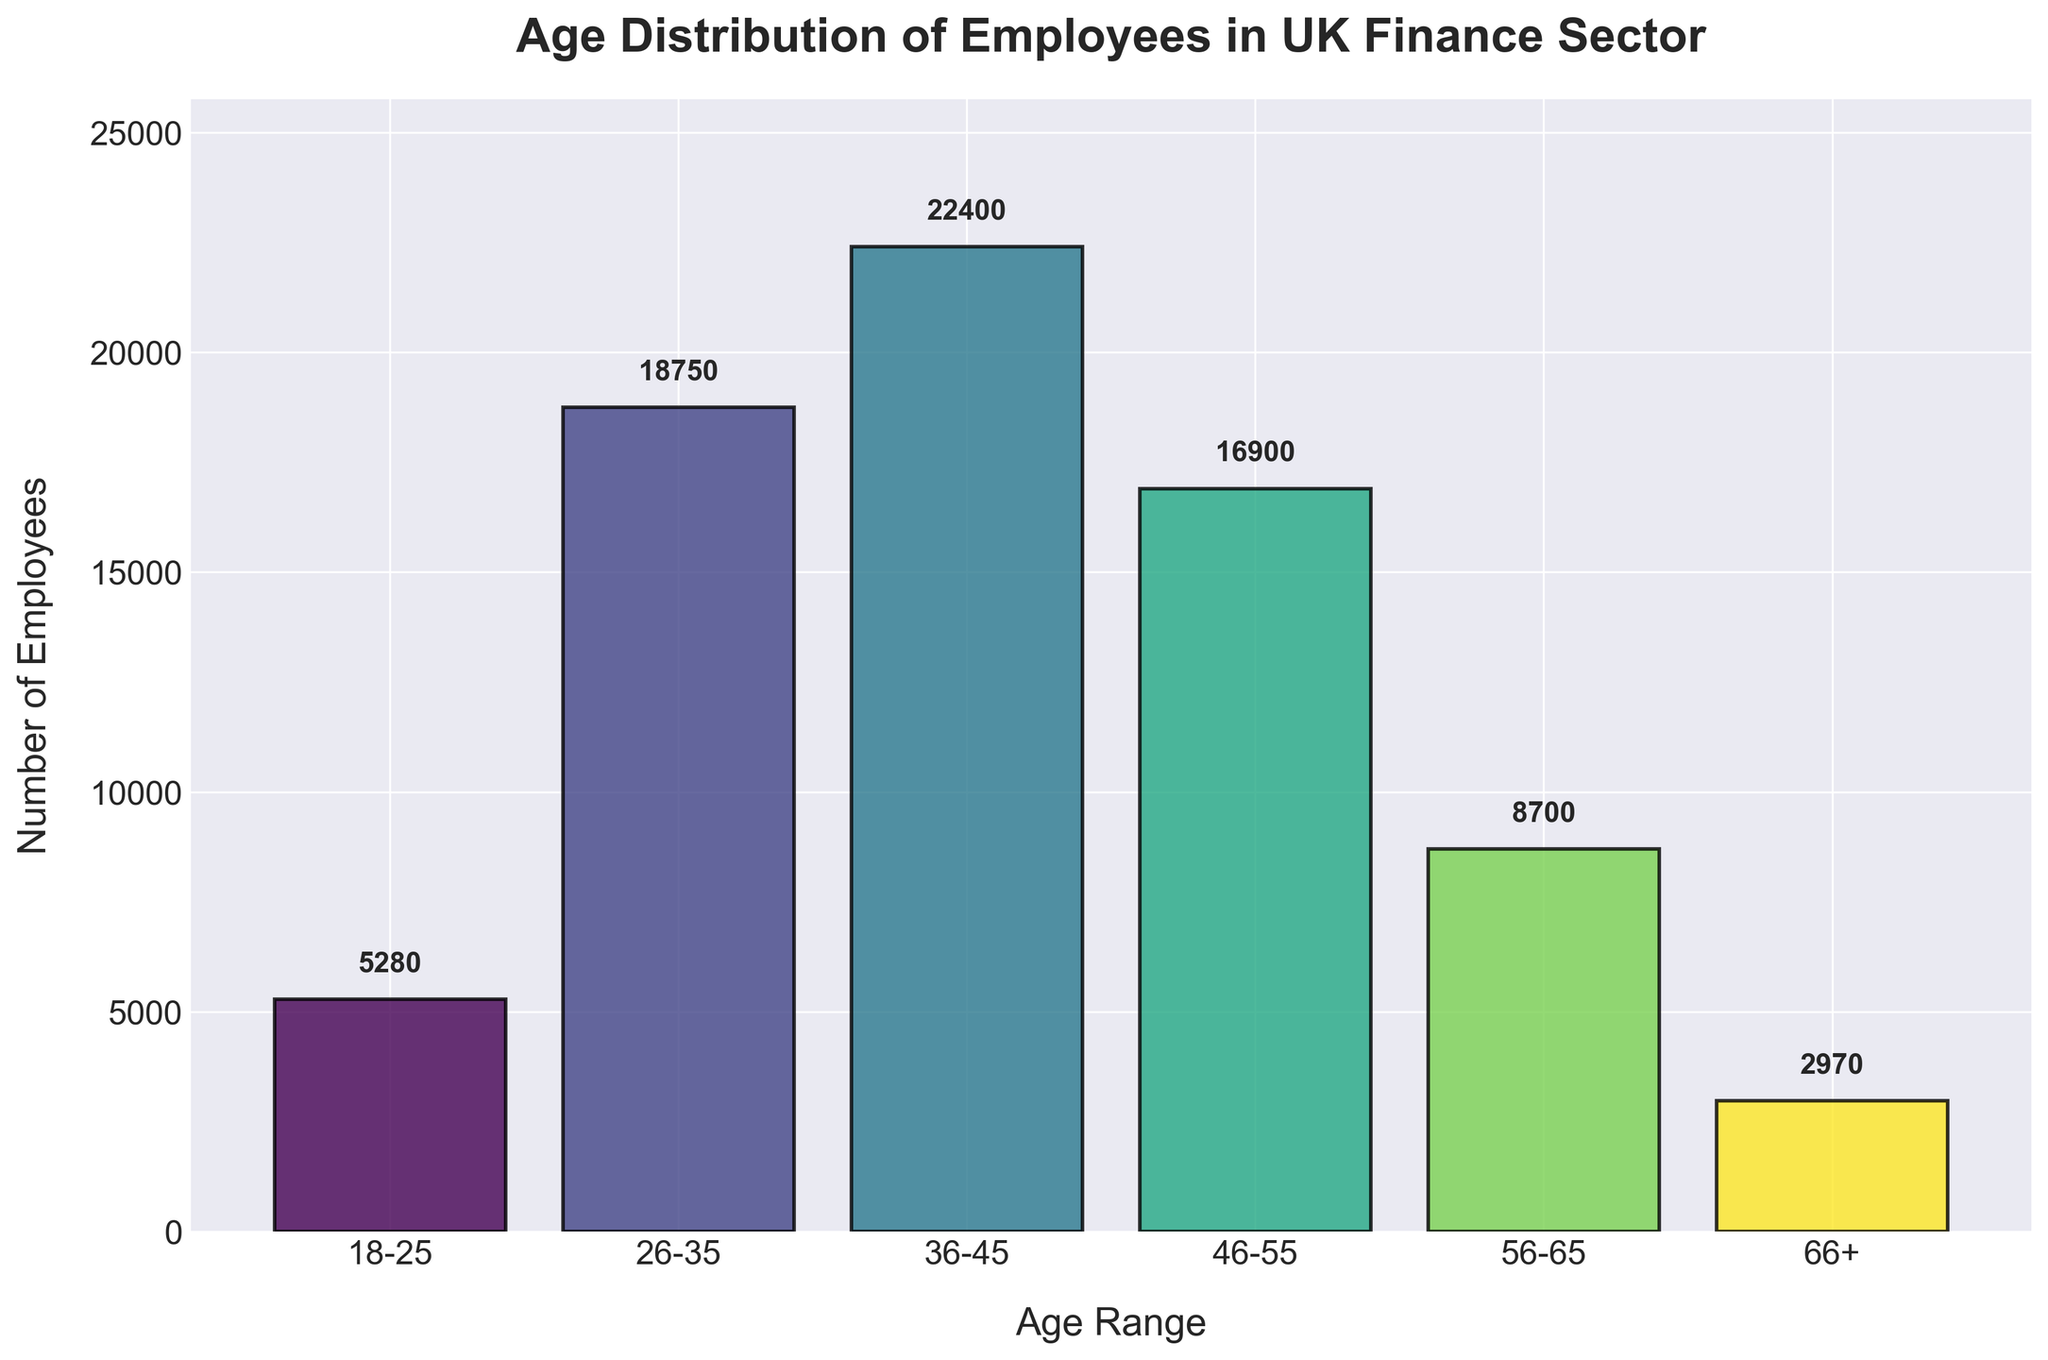How many age ranges are represented in the graph? Count the distinct age ranges shown in the x-axis of the graph. There are six age ranges displayed.
Answer: 6 What is the most populous age range? Identify the age range with the highest bar in the graph. The bar for the 36-45 age range is the tallest, indicating the highest number of employees.
Answer: 36-45 How many employees are aged between 46 and 55? Locate the bar labeled 46-55 on the x-axis and read the value at the top of the bar. The label above this bar shows that there are 16,900 employees in this age range.
Answer: 16,900 What is the total number of employees represented in the graph? Add the number of employees for all age ranges: 5280 + 18750 + 22400 + 16900 + 8700 + 2970. The sum is the total number of employees.
Answer: 75,000 Which age range has the fewest employees? Identify the shortest bar in the graph. The 66+ age range has the fewest employees, as indicated by the shortest bar.
Answer: 66+ How many more employees are there in the 36-45 age range compared to the 56-65 age range? Subtract the number of employees in the 56-65 age range from the number in the 36-45 age range: 22400 - 8700.
Answer: 13,700 Is there a noticeable decrease in the number of employees after the age of 45? Compare the number of employees in the 36-45 age range with the age ranges that follow. The number of employees decreases significantly from 22400 (36-45) to 16900 (46-55) and continues to decline in the older age ranges.
Answer: Yes What percentage of the total number of employees are aged 26-35? Divide the number of employees in the 26-35 age range by the total number of employees and multiply by 100: (18750 / 75000) * 100.
Answer: 25% How many age ranges have over 10,000 employees? Identify the bars that reach above 10,000 on the y-axis. Four age ranges (18-25, 26-35, 36-45, and 46-55) have over 10,000 employees.
Answer: 4 What is the combined number of employees aged between 18 and 45? Add the number of employees for the age ranges 18-25, 26-35, and 36-45: 5280 + 18750 + 22400. This is the combined total for employees in these age ranges.
Answer: 46,430 